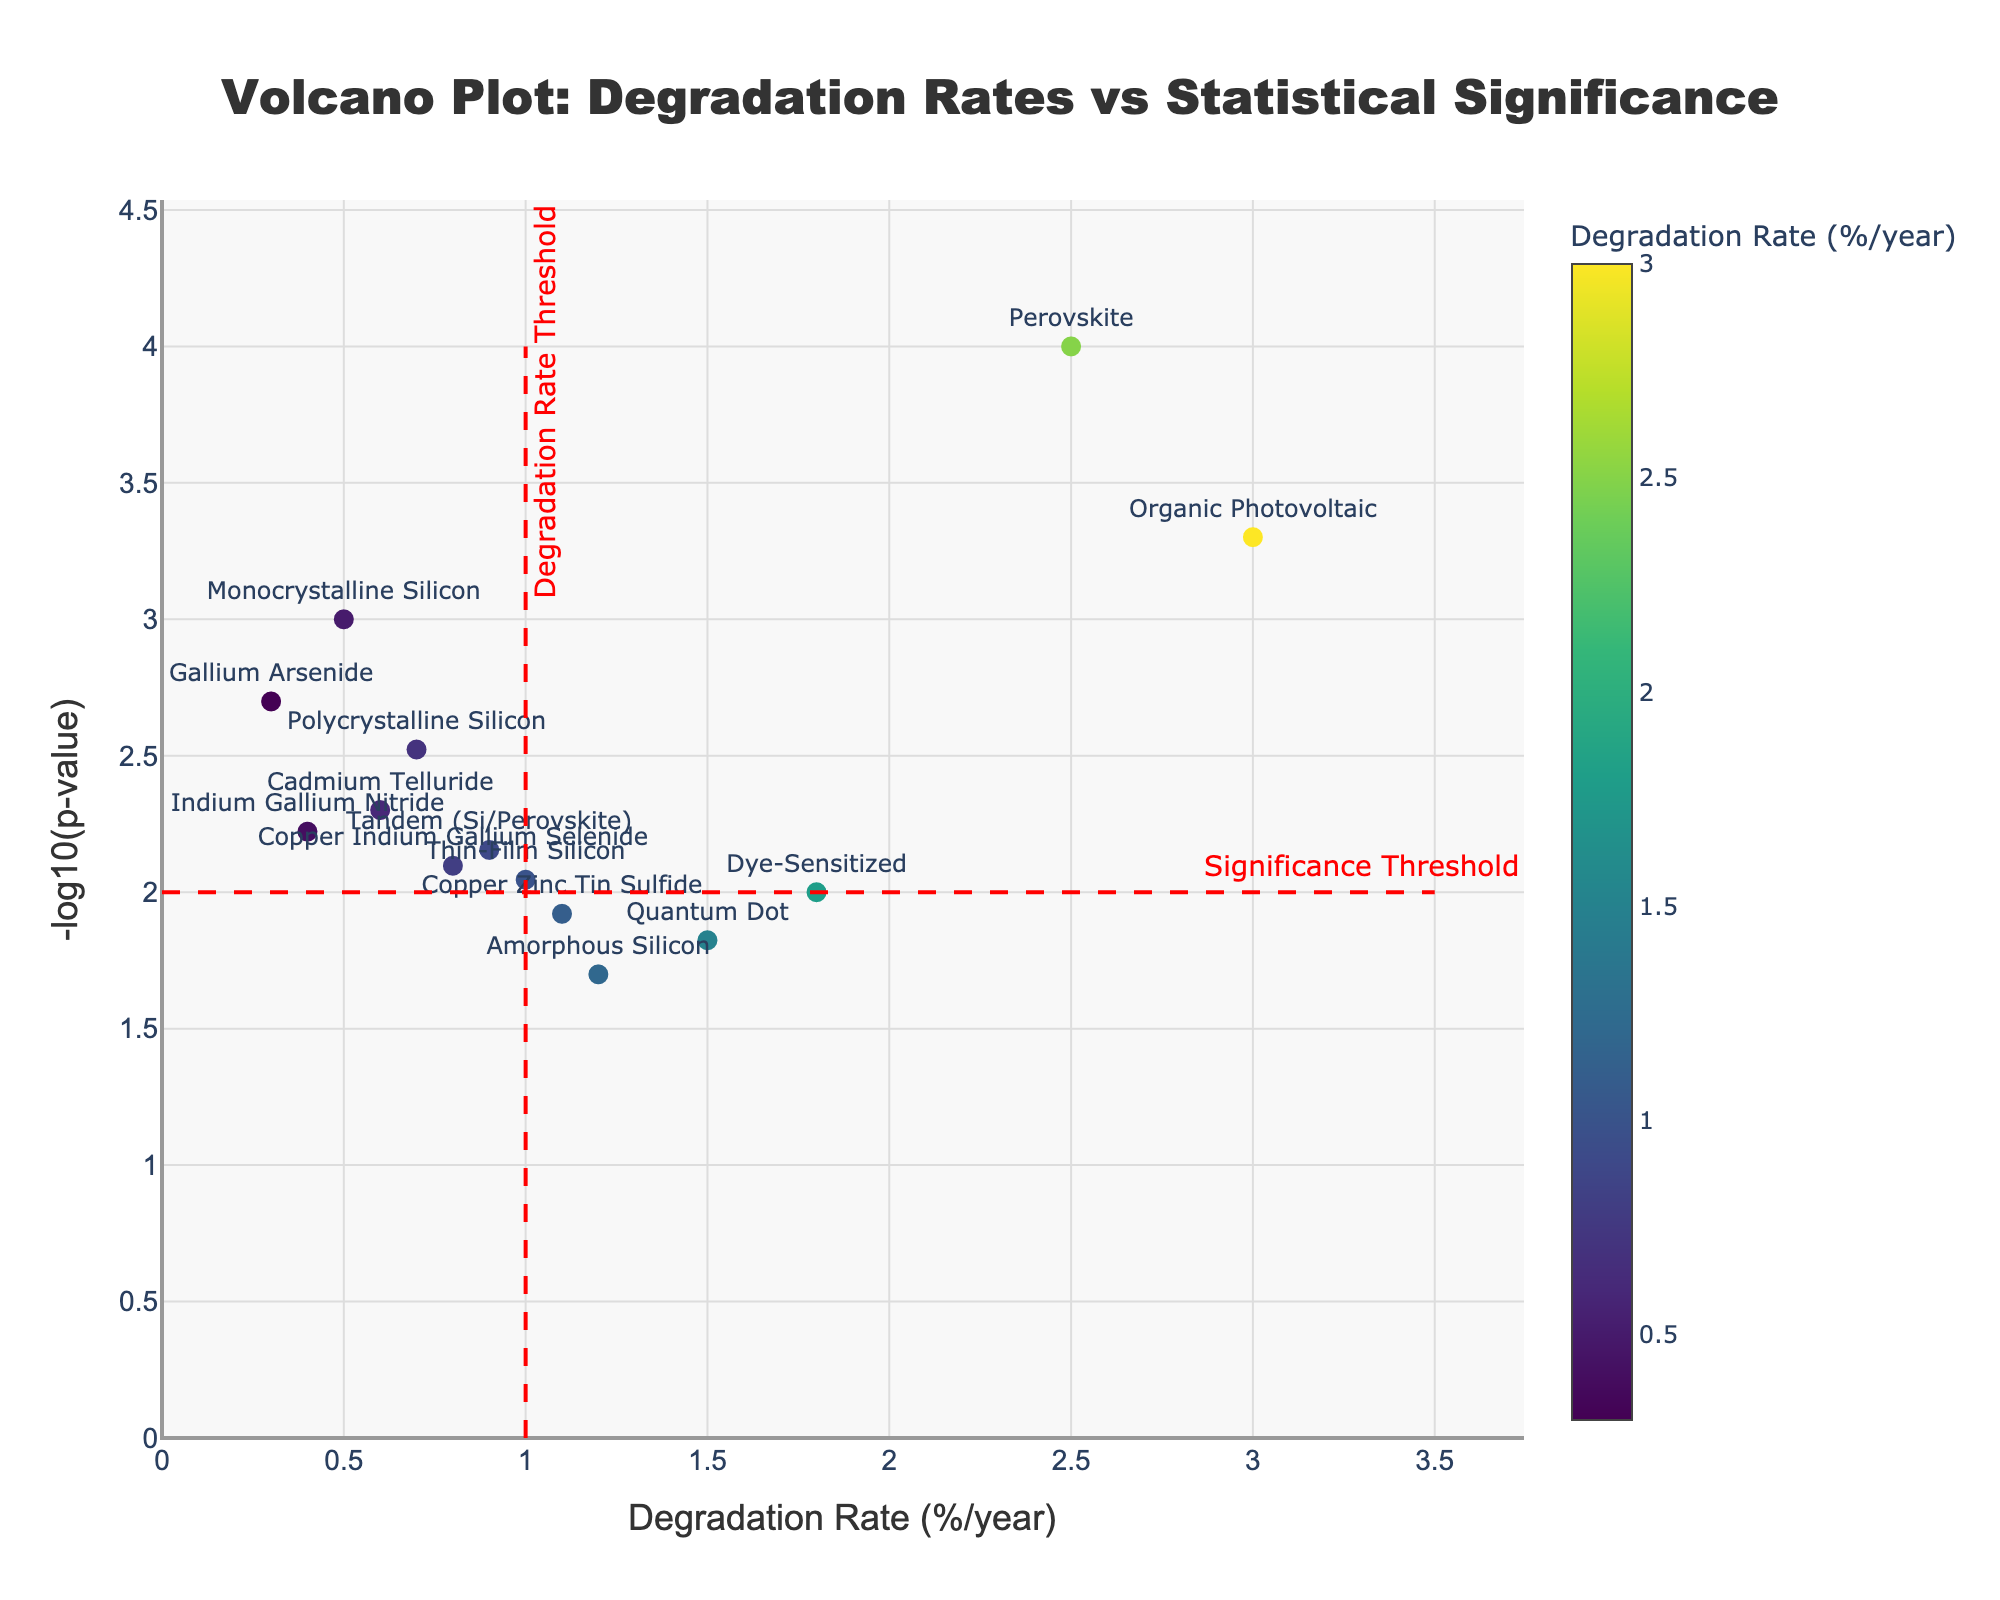Which material has the lowest degradation rate? To find the material with the lowest degradation rate, look at the x-axis of the plot for the smallest value. Gallium Arsenide with 0.3%/year is the lowest.
Answer: Gallium Arsenide What is the highest -log10(p-value) and which material does it correspond to? To determine this, look at the y-axis for the highest value and identify the corresponding material. Perovskite has the highest -log10(p-value) with a value of 4.
Answer: Perovskite How many materials have a degradation rate higher than 1.0% per year? Count the number of data points on the right side of the vertical red threshold line at 1.0 on the x-axis. There are 7 materials: Amorphous Silicon, Perovskite, Organic Photovoltaic, Dye-Sensitized, Quantum Dot, Thin-Film Silicon, Copper Zinc Tin Sulfide.
Answer: 7 Which material with a significant p-value (i.e., -log10(p-value) > 2) has the highest degradation rate? First, identify points above the horizontal threshold red line at y = 2. Then, among them, locate the one with the highest x-axis value. Organic Photovoltaic, with 3.0%/year, is the highest among the significant ones.
Answer: Organic Photovoltaic How many materials are both above the significance threshold (-log10(p-value) > 2) and below the degradation rate threshold (degradation rate < 1.0%/year)? Look for data points above the horizontal red line at y = 2 and left of the vertical red line at x = 1.0. There are 5 materials: Monocrystalline Silicon, Polycrystalline Silicon, Cadmium Telluride, Gallium Arsenide, Indium Gallium Nitride.
Answer: 5 What is the average degradation rate for materials in the significant region (-log10(p-value) > 2)? Identify the degradation rates for the materials above the horizontal red line: Monocrystalline Silicon, Polycrystalline Silicon, Gallium Arsenide, Organic Photovoltaic, Indium Gallium Nitride, Cadmium Telluride. Calculate their average: (0.5 + 0.7 + 0.3 + 3.0 + 0.4 + 0.6) / 6 = 0.917%/year.
Answer: 0.917%/year Are there any materials with a p-value lower than 0.001 but a degradation rate higher than 1% per year? Check for data points above y = 3 (since -log10(0.001) = 3) and right of x = 1.0. Perovskite (2.5%/year) and Organic Photovoltaic (3.0%/year) meet this criterion.
Answer: Yes, Perovskite and Organic Photovoltaic Which two materials have the closest degradation rates but different significance (one above and one below -log10(p-value) = 2)? Compare the x-values of materials across the horizontal red line at y = 2. Monocrystalline Silicon (0.5%/year) and Cadmium Telluride (0.6%/year) have close rates and different significances (one above and one below the line).
Answer: Monocrystalline Silicon and Cadmium Telluride What is the range of degradation rates for materials that are statistically significant (-log10(p-value) > 2)? Identify the minimum and maximum x-values of materials above the horizontal red line. The range is from Gallium Arsenide (0.3%/year) to Organic Photovoltaic (3.0%/year), giving a range of 3.0 - 0.3 = 2.7%/year.
Answer: 2.7%/year Which material has the highest degradation rate and what is its -log10(p-value)? Find the material with the highest x-value and note its y-value. Organic Photovoltaic has the highest degradation rate of 3.0%/year, with a -log10(p-value) of 3.3.
Answer: Organic Photovoltaic, 3.3 